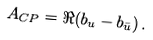<formula> <loc_0><loc_0><loc_500><loc_500>A _ { C P } = \Re ( b _ { u } - b _ { \bar { u } } ) \, .</formula> 